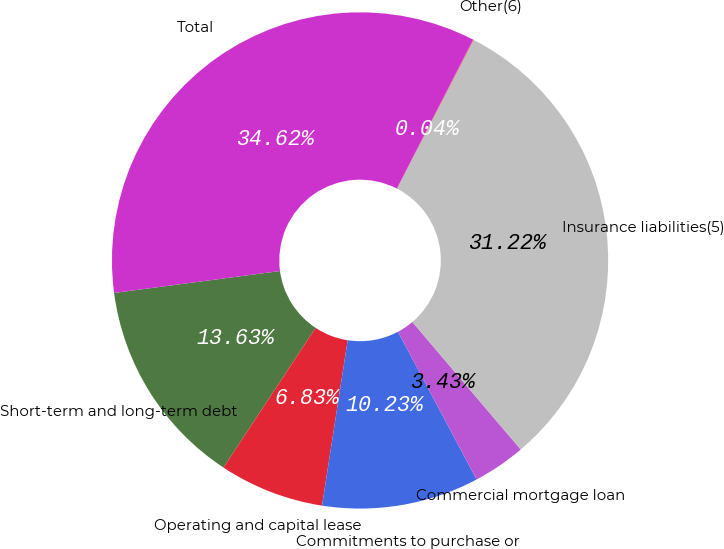Convert chart. <chart><loc_0><loc_0><loc_500><loc_500><pie_chart><fcel>Short-term and long-term debt<fcel>Operating and capital lease<fcel>Commitments to purchase or<fcel>Commercial mortgage loan<fcel>Insurance liabilities(5)<fcel>Other(6)<fcel>Total<nl><fcel>13.63%<fcel>6.83%<fcel>10.23%<fcel>3.43%<fcel>31.22%<fcel>0.04%<fcel>34.62%<nl></chart> 